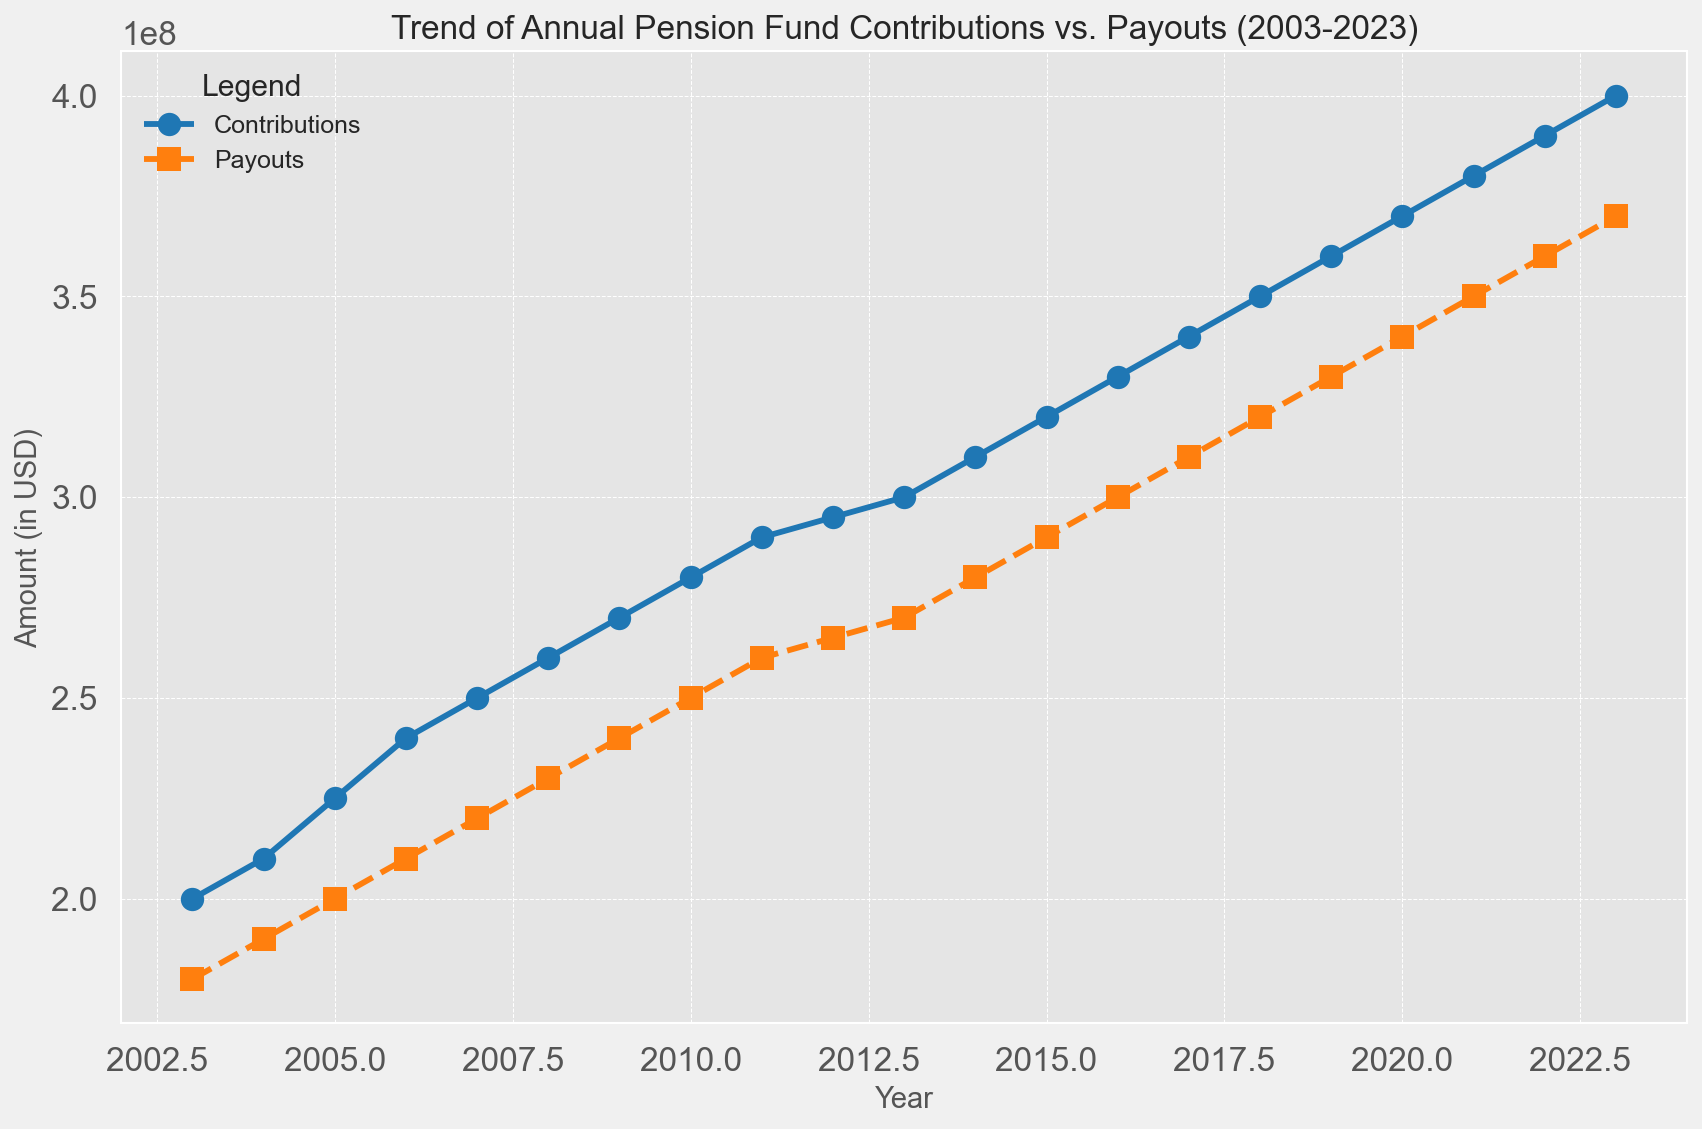What's the trend of contributions from 2003 to 2023? The contributions have shown a generally increasing trend over the years. Starting from $200 million in 2003 and steadily climbing to $400 million by 2023. This consistent increase each year reflects a positive growth.
Answer: Increasing trend What's the difference between contributions and payouts in 2023? In 2023, the contributions are $400 million, and the payouts are $370 million. The difference is calculated by subtracting payouts from contributions, which gives $400M - $370M = $30 million.
Answer: $30 million During which year is the gap between contributions and payouts the largest? For each year, the gap can be calculated by subtracting payouts from contributions. The largest difference appears in 2003, where contributions were $200 million and payouts were $180 million, giving a gap of $20 million. This is the highest compared to all other years.
Answer: 2003 How do the trends of contributions and payouts compare visually? Visually, contributions and payouts both show a similar increasing trend over the years; however, contributions consistently remain higher than payouts throughout the entire period. The lines on the graph are parallel, indicating a steady gap between them.
Answer: Both are increasing, contributions are consistently higher What is the average annual increase in contributions from 2003 to 2023? To find the average annual increase, subtract the contributions in 2003 from those in 2023 and divide by the number of years. The increase is $400M - $200M = $200 million over 20 years, so the average annual increase is $200M / 20 = $10 million per year.
Answer: $10 million Were there any years where contributions and payouts were equal? By checking each data point, we observe that in no year from 2003 to 2023 were the contributions and payouts equal. Contributions always exceed payouts.
Answer: No Which year shows the smallest increase in contributions compared to the previous year? By calculating the yearly increase in contributions, the smallest increase happened between 2011 and 2012, where contributions went from $290 million to $295 million, an increase of $5 million, which is the smallest seen.
Answer: 2012 What is the total amount contributed from 2003 to 2023? Adding up the contributions from each year from 2003 to 2023 gives a total of $6.93 billion.
Answer: $6.93 billion What color represents contributions on the chart? Contributions are represented by the blue line on the chart.
Answer: Blue In which year did payouts reach $300 million? Referring to the data and the chart, payouts reached $300 million in the year 2016.
Answer: 2016 